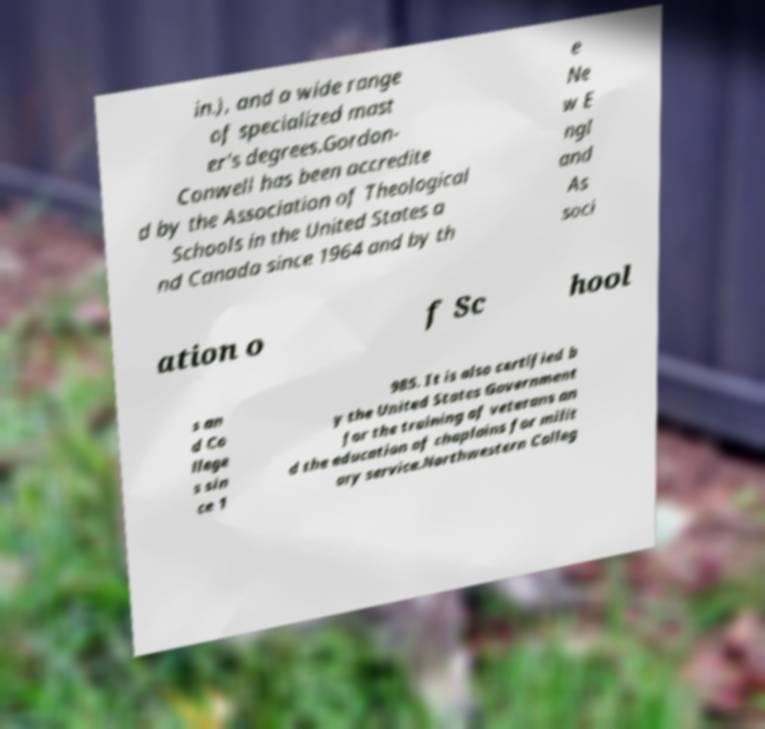For documentation purposes, I need the text within this image transcribed. Could you provide that? in.), and a wide range of specialized mast er's degrees.Gordon- Conwell has been accredite d by the Association of Theological Schools in the United States a nd Canada since 1964 and by th e Ne w E ngl and As soci ation o f Sc hool s an d Co llege s sin ce 1 985. It is also certified b y the United States Government for the training of veterans an d the education of chaplains for milit ary service.Northwestern Colleg 